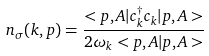Convert formula to latex. <formula><loc_0><loc_0><loc_500><loc_500>n _ { \sigma } ( { k } , { p } ) = \frac { < { p } , A | c ^ { \dagger } _ { k } c _ { k } | { p } , A > } { 2 \omega _ { k } < { p } , A | { p } , A > }</formula> 